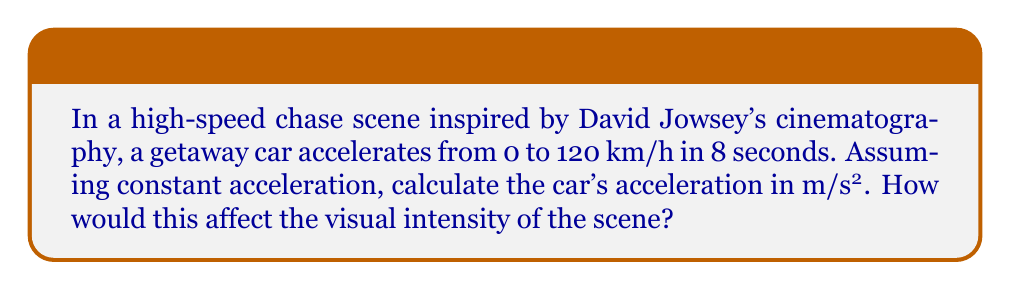What is the answer to this math problem? To solve this problem, we'll follow these steps:

1. Convert the given speed from km/h to m/s:
   $$ 120 \frac{\text{km}}{\text{h}} \times \frac{1000 \text{ m}}{1 \text{ km}} \times \frac{1 \text{ h}}{3600 \text{ s}} = 33.33 \frac{\text{m}}{\text{s}} $$

2. Use the equation for constant acceleration:
   $$ v = v_0 + at $$
   Where:
   $v$ is the final velocity (33.33 m/s)
   $v_0$ is the initial velocity (0 m/s)
   $a$ is the acceleration (unknown)
   $t$ is the time (8 seconds)

3. Substitute the values into the equation:
   $$ 33.33 = 0 + a(8) $$

4. Solve for $a$:
   $$ a = \frac{33.33}{8} = 4.17 \frac{\text{m}}{\text{s}^2} $$

5. Visual intensity:
   This rapid acceleration would create a sense of intense speed and urgency in the scene. The quick buildup of velocity would be visually apparent through the rapidly changing scenery and the physical reactions of the characters inside the vehicle.
Answer: $4.17 \frac{\text{m}}{\text{s}^2}$ 